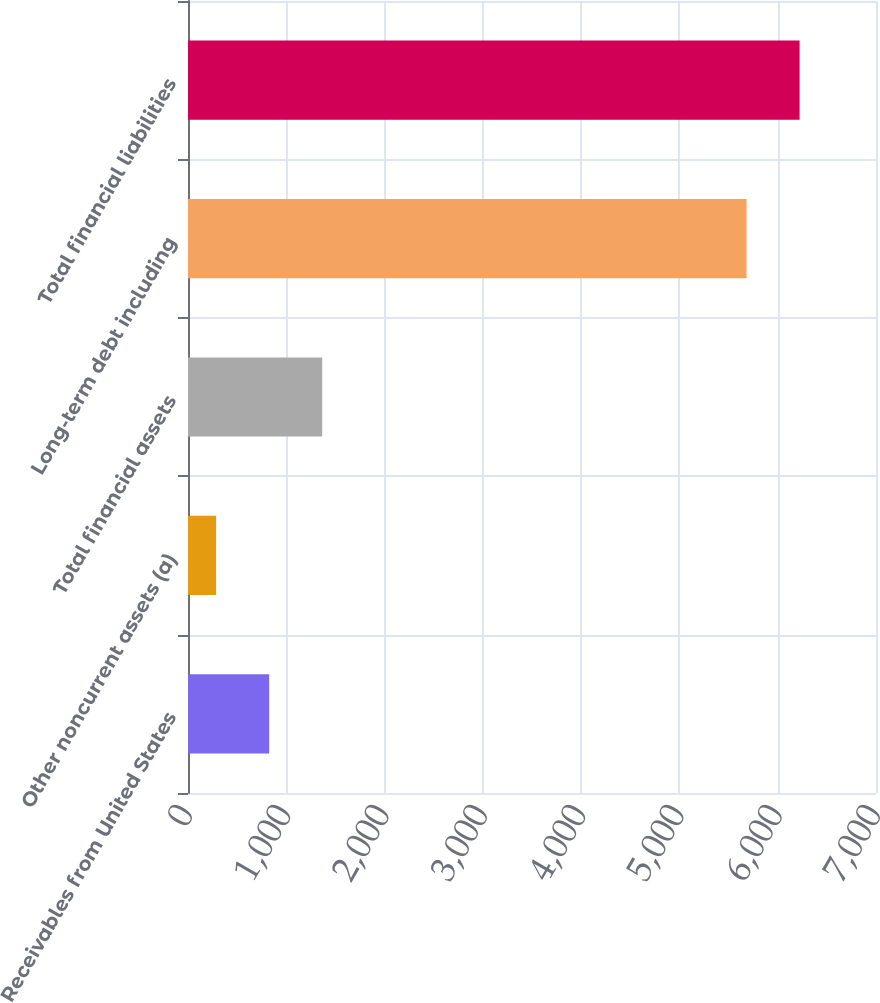<chart> <loc_0><loc_0><loc_500><loc_500><bar_chart><fcel>Receivables from United States<fcel>Other noncurrent assets (a)<fcel>Total financial assets<fcel>Long-term debt including<fcel>Total financial liabilities<nl><fcel>825.7<fcel>286<fcel>1365.4<fcel>5683<fcel>6222.7<nl></chart> 